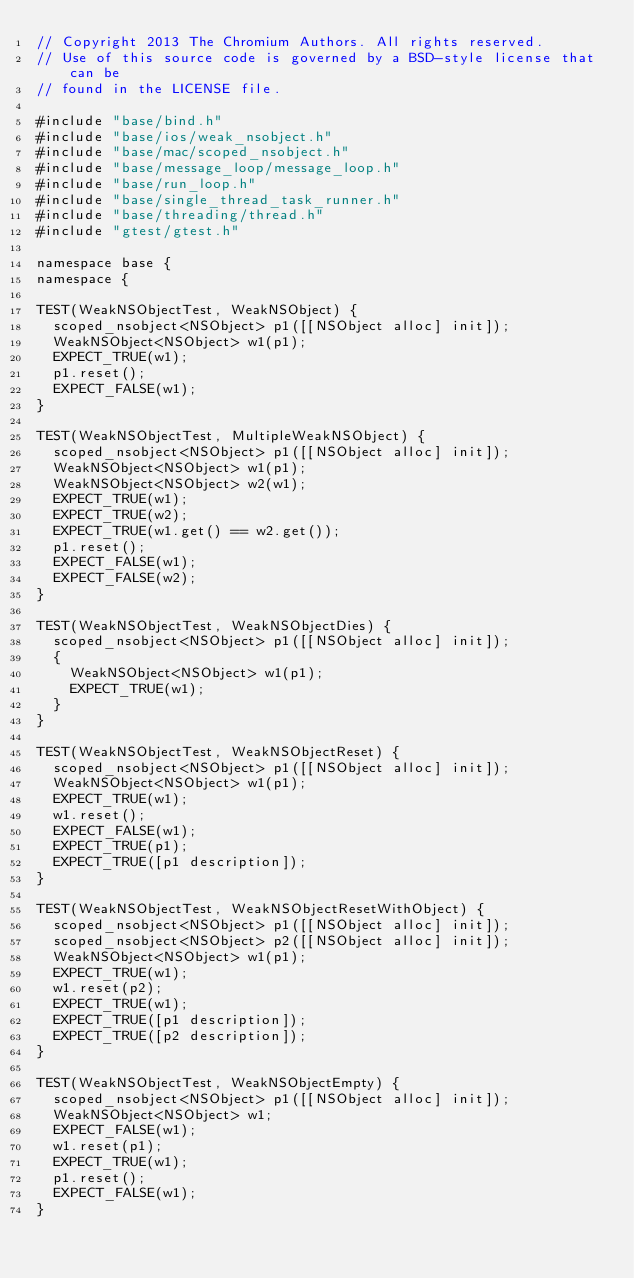<code> <loc_0><loc_0><loc_500><loc_500><_ObjectiveC_>// Copyright 2013 The Chromium Authors. All rights reserved.
// Use of this source code is governed by a BSD-style license that can be
// found in the LICENSE file.

#include "base/bind.h"
#include "base/ios/weak_nsobject.h"
#include "base/mac/scoped_nsobject.h"
#include "base/message_loop/message_loop.h"
#include "base/run_loop.h"
#include "base/single_thread_task_runner.h"
#include "base/threading/thread.h"
#include "gtest/gtest.h"

namespace base {
namespace {

TEST(WeakNSObjectTest, WeakNSObject) {
  scoped_nsobject<NSObject> p1([[NSObject alloc] init]);
  WeakNSObject<NSObject> w1(p1);
  EXPECT_TRUE(w1);
  p1.reset();
  EXPECT_FALSE(w1);
}

TEST(WeakNSObjectTest, MultipleWeakNSObject) {
  scoped_nsobject<NSObject> p1([[NSObject alloc] init]);
  WeakNSObject<NSObject> w1(p1);
  WeakNSObject<NSObject> w2(w1);
  EXPECT_TRUE(w1);
  EXPECT_TRUE(w2);
  EXPECT_TRUE(w1.get() == w2.get());
  p1.reset();
  EXPECT_FALSE(w1);
  EXPECT_FALSE(w2);
}

TEST(WeakNSObjectTest, WeakNSObjectDies) {
  scoped_nsobject<NSObject> p1([[NSObject alloc] init]);
  {
    WeakNSObject<NSObject> w1(p1);
    EXPECT_TRUE(w1);
  }
}

TEST(WeakNSObjectTest, WeakNSObjectReset) {
  scoped_nsobject<NSObject> p1([[NSObject alloc] init]);
  WeakNSObject<NSObject> w1(p1);
  EXPECT_TRUE(w1);
  w1.reset();
  EXPECT_FALSE(w1);
  EXPECT_TRUE(p1);
  EXPECT_TRUE([p1 description]);
}

TEST(WeakNSObjectTest, WeakNSObjectResetWithObject) {
  scoped_nsobject<NSObject> p1([[NSObject alloc] init]);
  scoped_nsobject<NSObject> p2([[NSObject alloc] init]);
  WeakNSObject<NSObject> w1(p1);
  EXPECT_TRUE(w1);
  w1.reset(p2);
  EXPECT_TRUE(w1);
  EXPECT_TRUE([p1 description]);
  EXPECT_TRUE([p2 description]);
}

TEST(WeakNSObjectTest, WeakNSObjectEmpty) {
  scoped_nsobject<NSObject> p1([[NSObject alloc] init]);
  WeakNSObject<NSObject> w1;
  EXPECT_FALSE(w1);
  w1.reset(p1);
  EXPECT_TRUE(w1);
  p1.reset();
  EXPECT_FALSE(w1);
}
</code> 